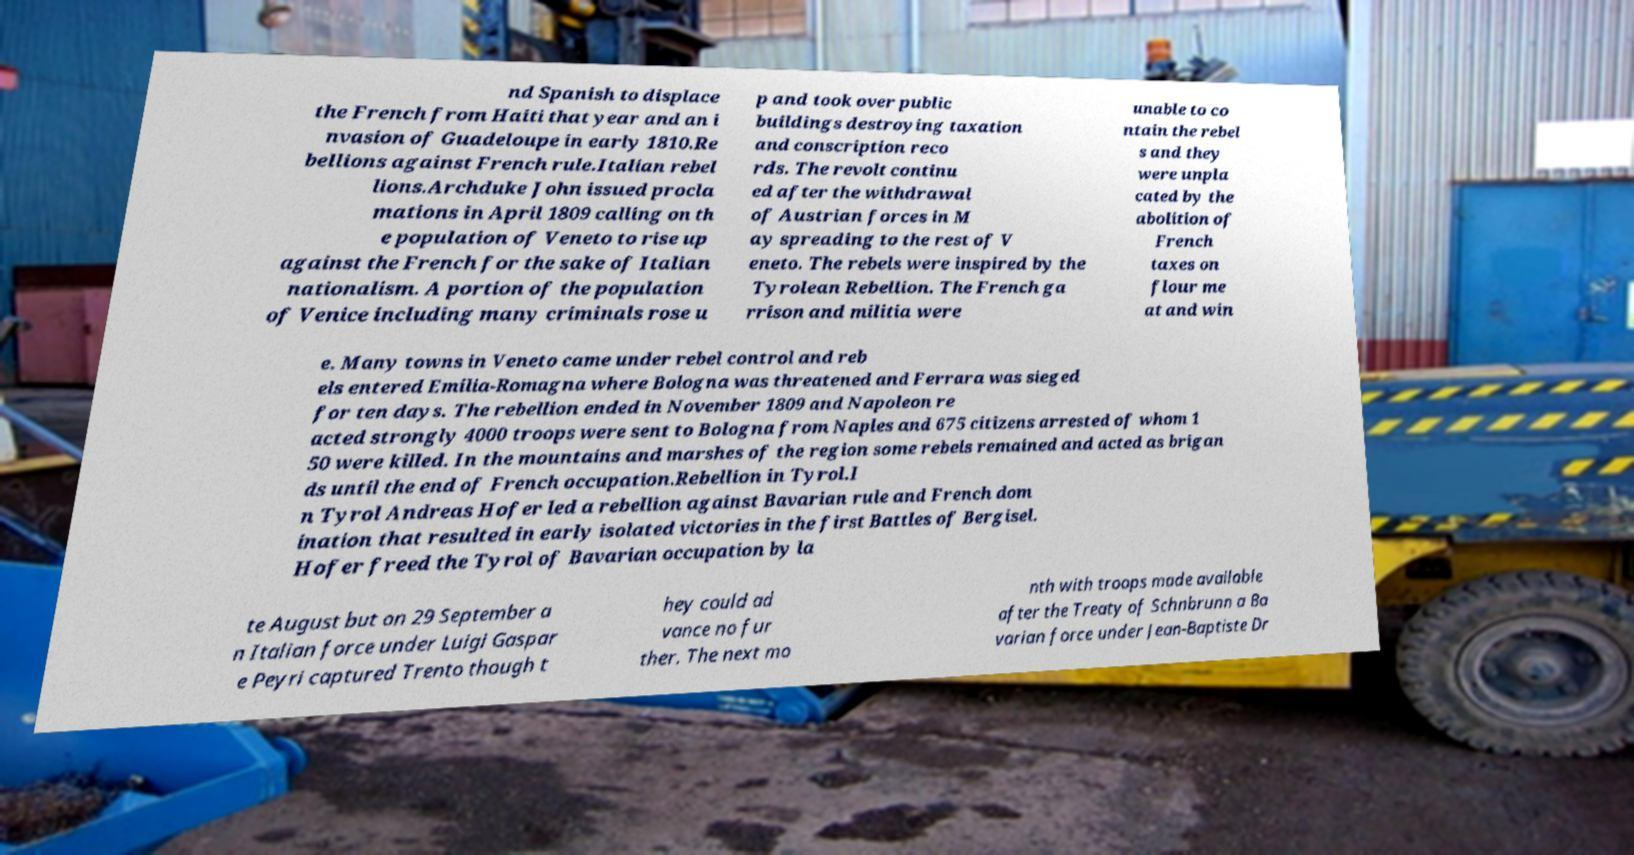There's text embedded in this image that I need extracted. Can you transcribe it verbatim? nd Spanish to displace the French from Haiti that year and an i nvasion of Guadeloupe in early 1810.Re bellions against French rule.Italian rebel lions.Archduke John issued procla mations in April 1809 calling on th e population of Veneto to rise up against the French for the sake of Italian nationalism. A portion of the population of Venice including many criminals rose u p and took over public buildings destroying taxation and conscription reco rds. The revolt continu ed after the withdrawal of Austrian forces in M ay spreading to the rest of V eneto. The rebels were inspired by the Tyrolean Rebellion. The French ga rrison and militia were unable to co ntain the rebel s and they were unpla cated by the abolition of French taxes on flour me at and win e. Many towns in Veneto came under rebel control and reb els entered Emilia-Romagna where Bologna was threatened and Ferrara was sieged for ten days. The rebellion ended in November 1809 and Napoleon re acted strongly 4000 troops were sent to Bologna from Naples and 675 citizens arrested of whom 1 50 were killed. In the mountains and marshes of the region some rebels remained and acted as brigan ds until the end of French occupation.Rebellion in Tyrol.I n Tyrol Andreas Hofer led a rebellion against Bavarian rule and French dom ination that resulted in early isolated victories in the first Battles of Bergisel. Hofer freed the Tyrol of Bavarian occupation by la te August but on 29 September a n Italian force under Luigi Gaspar e Peyri captured Trento though t hey could ad vance no fur ther. The next mo nth with troops made available after the Treaty of Schnbrunn a Ba varian force under Jean-Baptiste Dr 